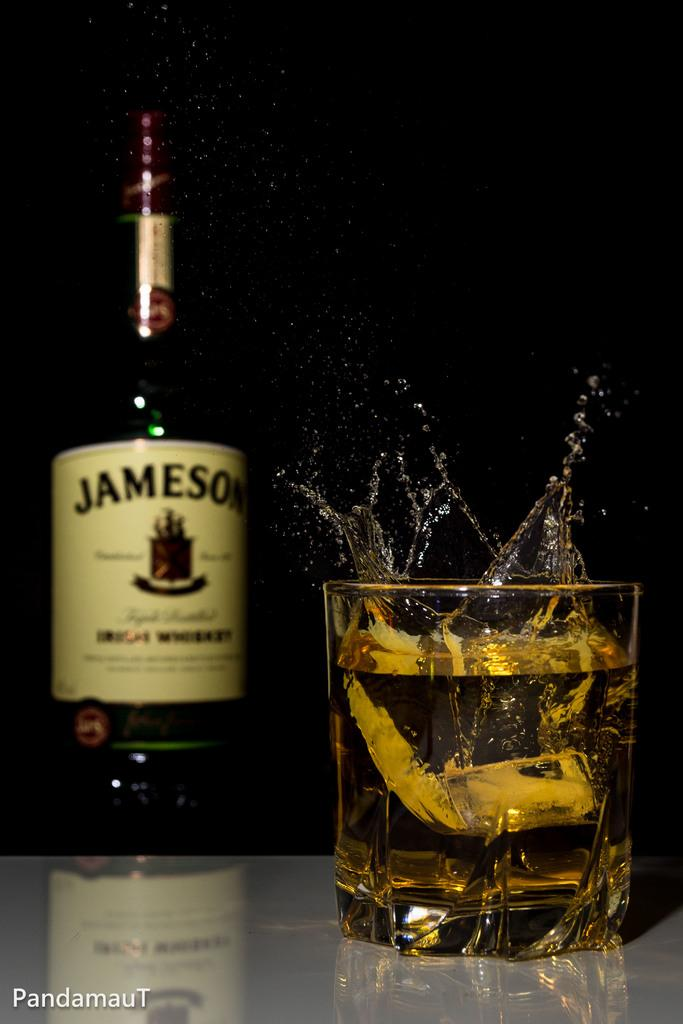<image>
Provide a brief description of the given image. A bottle on Jameson Irish Whiskey is next to a glass of whiskey. 